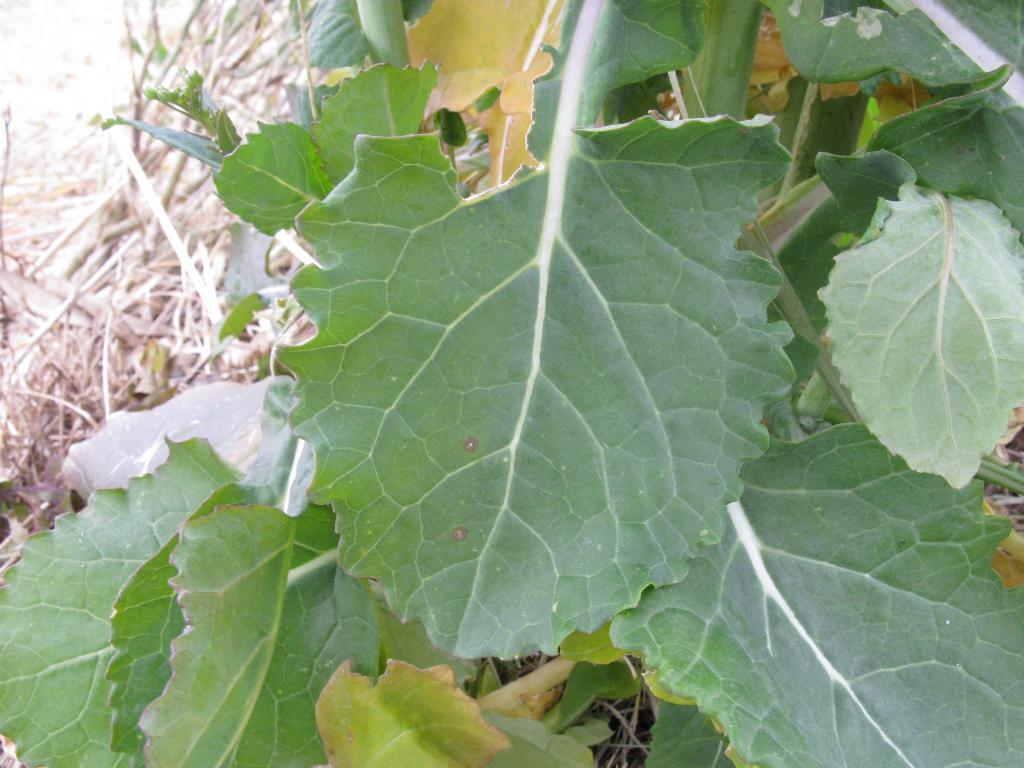Could you give a brief overview of what you see in this image? This picture shows a tree with green leaves and we see dry grass on the ground. 